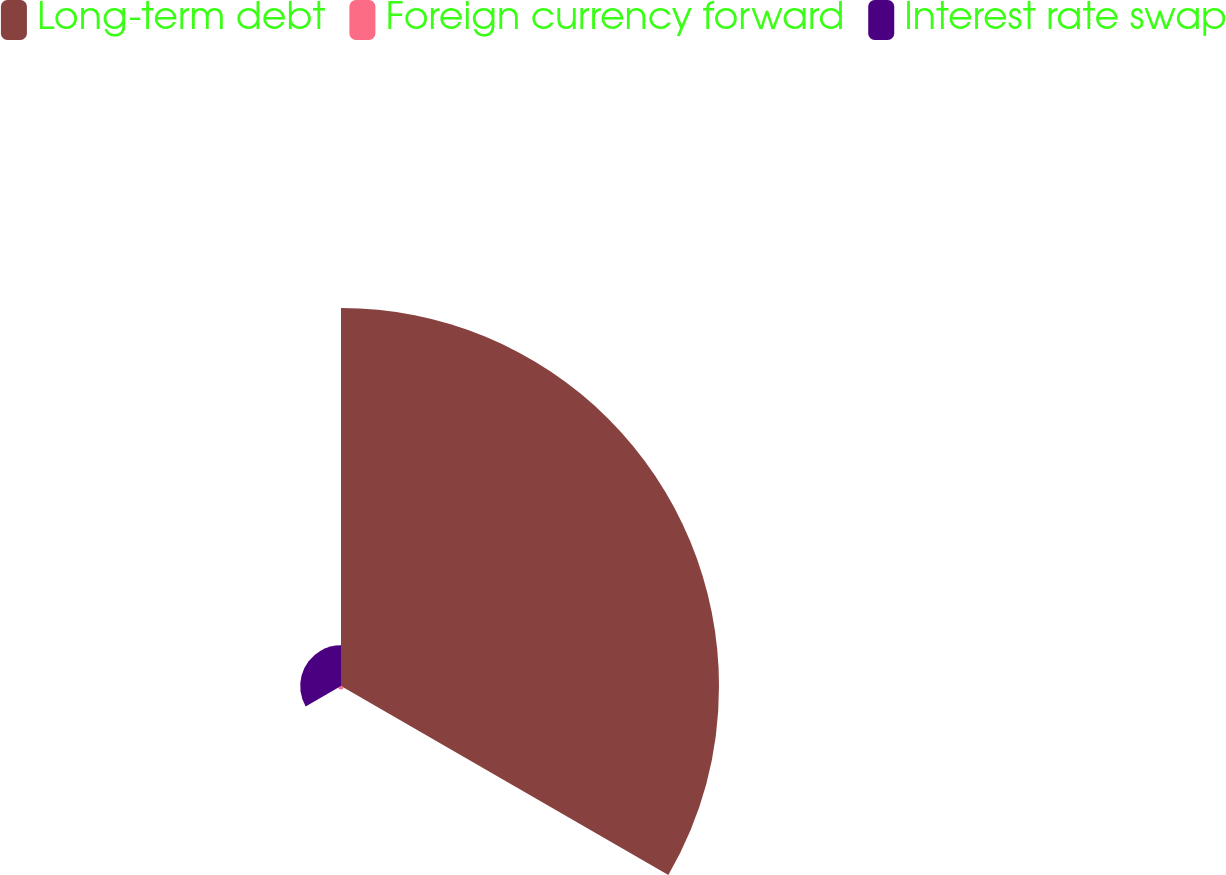Convert chart. <chart><loc_0><loc_0><loc_500><loc_500><pie_chart><fcel>Long-term debt<fcel>Foreign currency forward<fcel>Interest rate swap<nl><fcel>89.54%<fcel>0.79%<fcel>9.67%<nl></chart> 